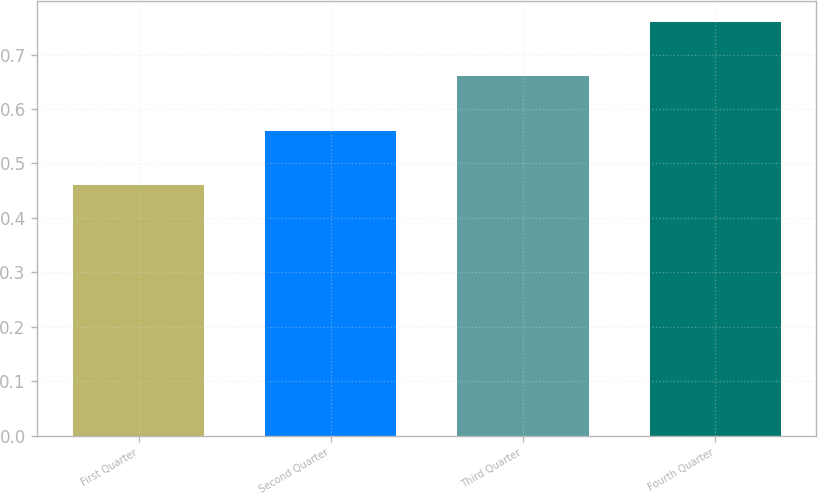Convert chart to OTSL. <chart><loc_0><loc_0><loc_500><loc_500><bar_chart><fcel>First Quarter<fcel>Second Quarter<fcel>Third Quarter<fcel>Fourth Quarter<nl><fcel>0.46<fcel>0.56<fcel>0.66<fcel>0.76<nl></chart> 